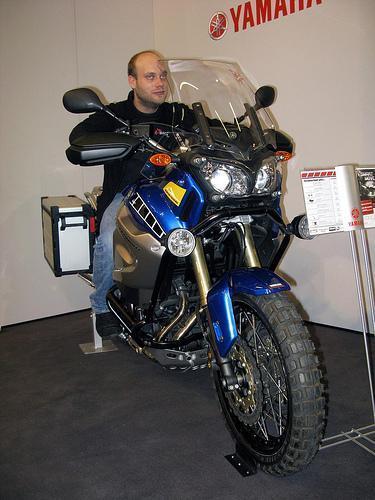How many motorcycles are there?
Give a very brief answer. 1. 